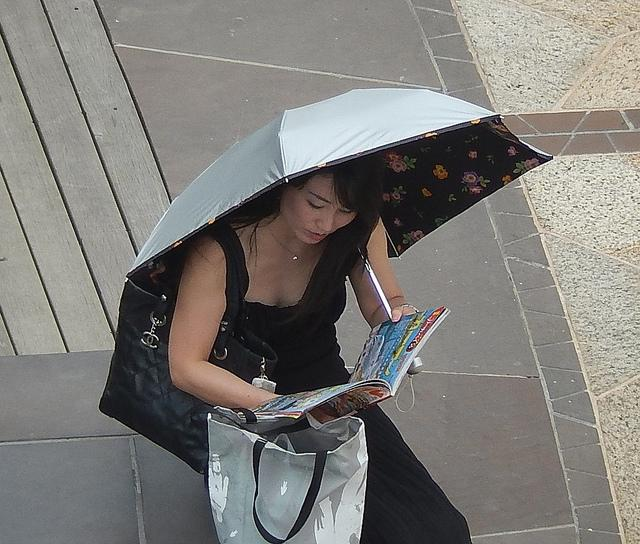What does the lady use the umbrella for? shade 